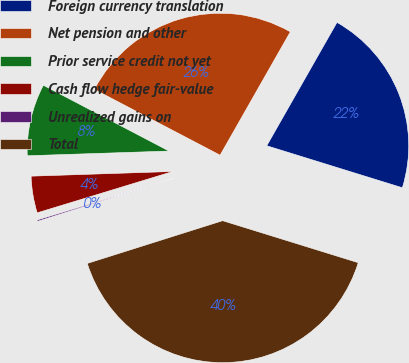Convert chart. <chart><loc_0><loc_0><loc_500><loc_500><pie_chart><fcel>Foreign currency translation<fcel>Net pension and other<fcel>Prior service credit not yet<fcel>Cash flow hedge fair-value<fcel>Unrealized gains on<fcel>Total<nl><fcel>21.54%<fcel>25.56%<fcel>8.2%<fcel>4.18%<fcel>0.16%<fcel>40.35%<nl></chart> 